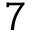<formula> <loc_0><loc_0><loc_500><loc_500>7</formula> 